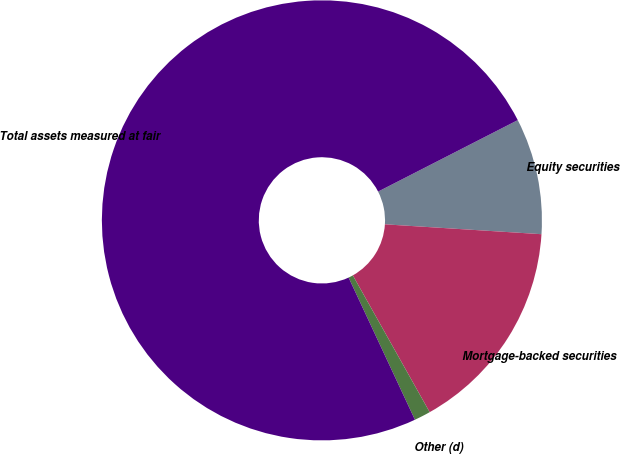Convert chart. <chart><loc_0><loc_0><loc_500><loc_500><pie_chart><fcel>Equity securities<fcel>Mortgage-backed securities<fcel>Other (d)<fcel>Total assets measured at fair<nl><fcel>8.53%<fcel>15.85%<fcel>1.2%<fcel>74.42%<nl></chart> 